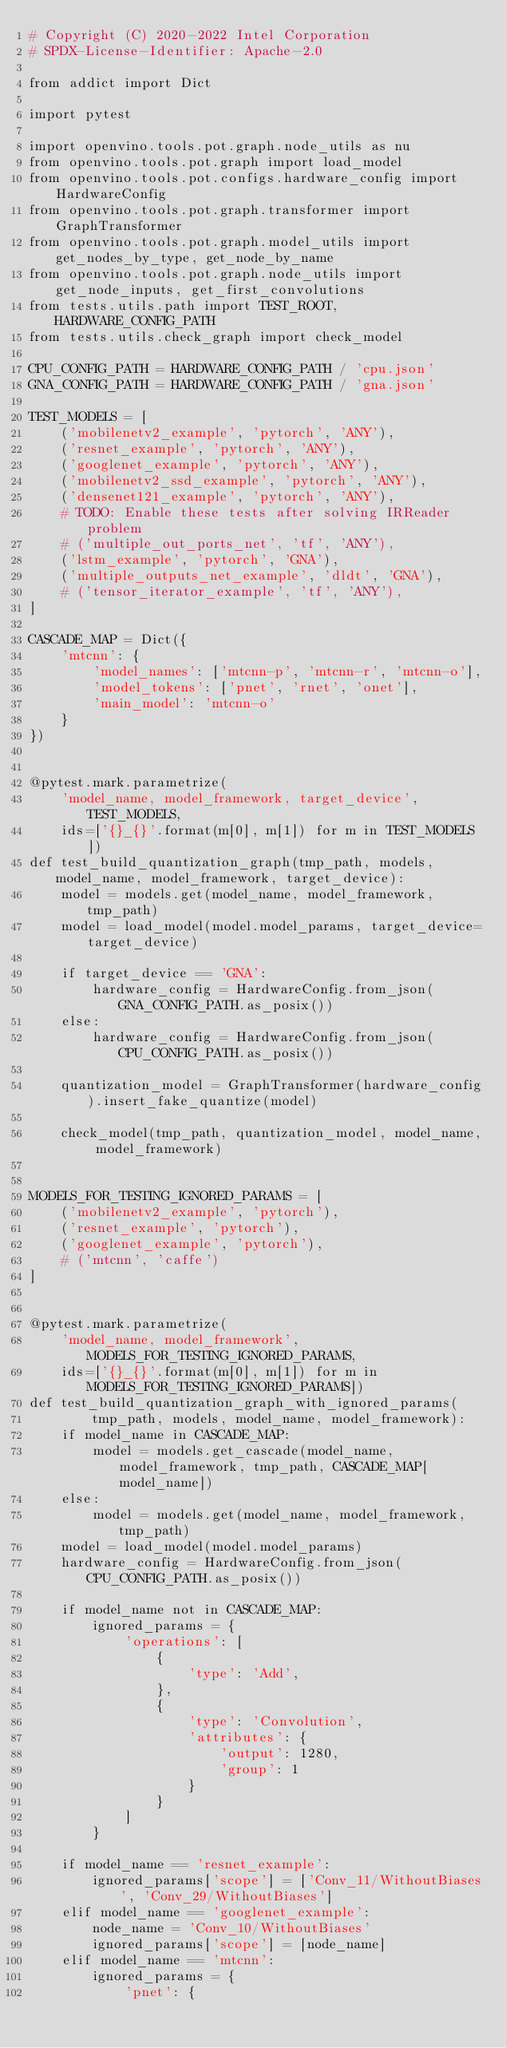<code> <loc_0><loc_0><loc_500><loc_500><_Python_># Copyright (C) 2020-2022 Intel Corporation
# SPDX-License-Identifier: Apache-2.0

from addict import Dict

import pytest

import openvino.tools.pot.graph.node_utils as nu
from openvino.tools.pot.graph import load_model
from openvino.tools.pot.configs.hardware_config import HardwareConfig
from openvino.tools.pot.graph.transformer import GraphTransformer
from openvino.tools.pot.graph.model_utils import get_nodes_by_type, get_node_by_name
from openvino.tools.pot.graph.node_utils import get_node_inputs, get_first_convolutions
from tests.utils.path import TEST_ROOT, HARDWARE_CONFIG_PATH
from tests.utils.check_graph import check_model

CPU_CONFIG_PATH = HARDWARE_CONFIG_PATH / 'cpu.json'
GNA_CONFIG_PATH = HARDWARE_CONFIG_PATH / 'gna.json'

TEST_MODELS = [
    ('mobilenetv2_example', 'pytorch', 'ANY'),
    ('resnet_example', 'pytorch', 'ANY'),
    ('googlenet_example', 'pytorch', 'ANY'),
    ('mobilenetv2_ssd_example', 'pytorch', 'ANY'),
    ('densenet121_example', 'pytorch', 'ANY'),
    # TODO: Enable these tests after solving IRReader problem
    # ('multiple_out_ports_net', 'tf', 'ANY'),
    ('lstm_example', 'pytorch', 'GNA'),
    ('multiple_outputs_net_example', 'dldt', 'GNA'),
    # ('tensor_iterator_example', 'tf', 'ANY'),
]

CASCADE_MAP = Dict({
    'mtcnn': {
        'model_names': ['mtcnn-p', 'mtcnn-r', 'mtcnn-o'],
        'model_tokens': ['pnet', 'rnet', 'onet'],
        'main_model': 'mtcnn-o'
    }
})


@pytest.mark.parametrize(
    'model_name, model_framework, target_device', TEST_MODELS,
    ids=['{}_{}'.format(m[0], m[1]) for m in TEST_MODELS])
def test_build_quantization_graph(tmp_path, models, model_name, model_framework, target_device):
    model = models.get(model_name, model_framework, tmp_path)
    model = load_model(model.model_params, target_device=target_device)

    if target_device == 'GNA':
        hardware_config = HardwareConfig.from_json(GNA_CONFIG_PATH.as_posix())
    else:
        hardware_config = HardwareConfig.from_json(CPU_CONFIG_PATH.as_posix())

    quantization_model = GraphTransformer(hardware_config).insert_fake_quantize(model)

    check_model(tmp_path, quantization_model, model_name, model_framework)


MODELS_FOR_TESTING_IGNORED_PARAMS = [
    ('mobilenetv2_example', 'pytorch'),
    ('resnet_example', 'pytorch'),
    ('googlenet_example', 'pytorch'),
    # ('mtcnn', 'caffe')
]


@pytest.mark.parametrize(
    'model_name, model_framework', MODELS_FOR_TESTING_IGNORED_PARAMS,
    ids=['{}_{}'.format(m[0], m[1]) for m in MODELS_FOR_TESTING_IGNORED_PARAMS])
def test_build_quantization_graph_with_ignored_params(
        tmp_path, models, model_name, model_framework):
    if model_name in CASCADE_MAP:
        model = models.get_cascade(model_name, model_framework, tmp_path, CASCADE_MAP[model_name])
    else:
        model = models.get(model_name, model_framework, tmp_path)
    model = load_model(model.model_params)
    hardware_config = HardwareConfig.from_json(CPU_CONFIG_PATH.as_posix())

    if model_name not in CASCADE_MAP:
        ignored_params = {
            'operations': [
                {
                    'type': 'Add',
                },
                {
                    'type': 'Convolution',
                    'attributes': {
                        'output': 1280,
                        'group': 1
                    }
                }
            ]
        }

    if model_name == 'resnet_example':
        ignored_params['scope'] = ['Conv_11/WithoutBiases', 'Conv_29/WithoutBiases']
    elif model_name == 'googlenet_example':
        node_name = 'Conv_10/WithoutBiases'
        ignored_params['scope'] = [node_name]
    elif model_name == 'mtcnn':
        ignored_params = {
            'pnet': {</code> 